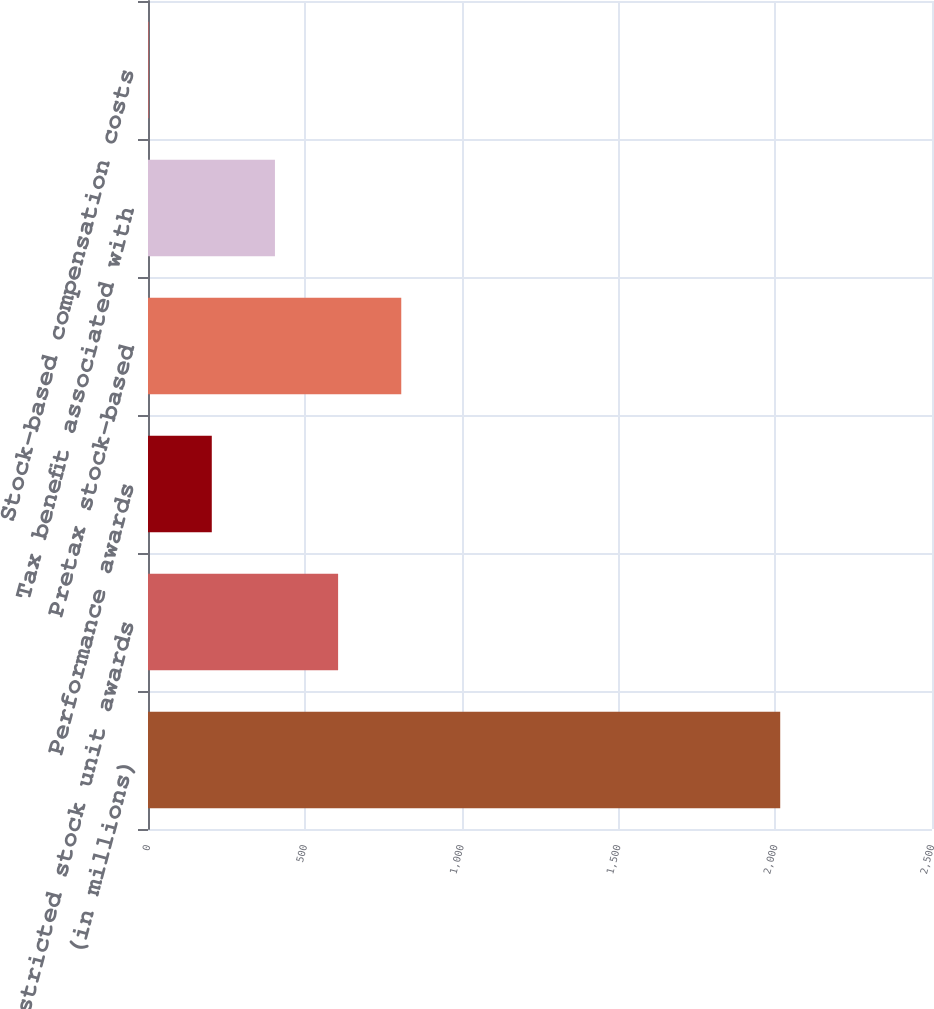Convert chart to OTSL. <chart><loc_0><loc_0><loc_500><loc_500><bar_chart><fcel>(in millions)<fcel>Restricted stock unit awards<fcel>Performance awards<fcel>Pretax stock-based<fcel>Tax benefit associated with<fcel>Stock-based compensation costs<nl><fcel>2016<fcel>606.2<fcel>203.4<fcel>807.6<fcel>404.8<fcel>2<nl></chart> 